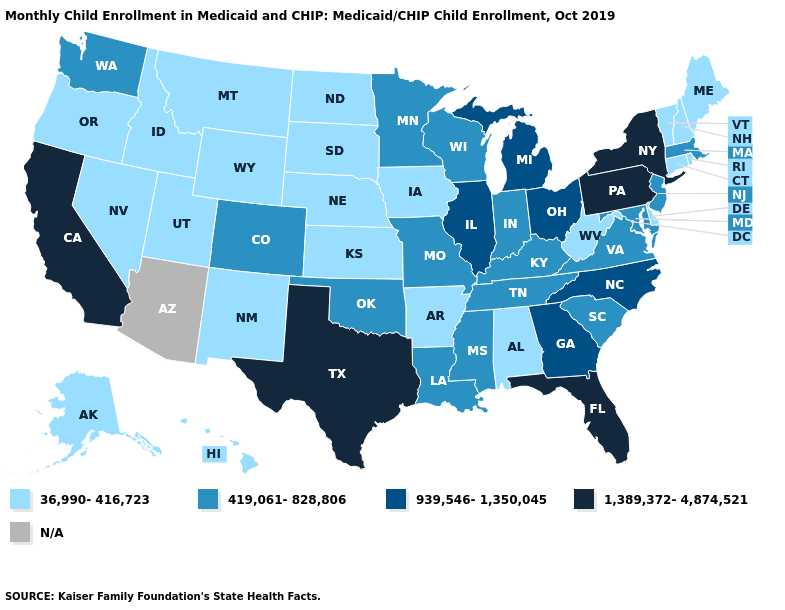Name the states that have a value in the range N/A?
Quick response, please. Arizona. Does the first symbol in the legend represent the smallest category?
Keep it brief. Yes. Name the states that have a value in the range 36,990-416,723?
Write a very short answer. Alabama, Alaska, Arkansas, Connecticut, Delaware, Hawaii, Idaho, Iowa, Kansas, Maine, Montana, Nebraska, Nevada, New Hampshire, New Mexico, North Dakota, Oregon, Rhode Island, South Dakota, Utah, Vermont, West Virginia, Wyoming. Name the states that have a value in the range 36,990-416,723?
Give a very brief answer. Alabama, Alaska, Arkansas, Connecticut, Delaware, Hawaii, Idaho, Iowa, Kansas, Maine, Montana, Nebraska, Nevada, New Hampshire, New Mexico, North Dakota, Oregon, Rhode Island, South Dakota, Utah, Vermont, West Virginia, Wyoming. What is the lowest value in states that border Tennessee?
Keep it brief. 36,990-416,723. Name the states that have a value in the range N/A?
Short answer required. Arizona. What is the value of Kentucky?
Be succinct. 419,061-828,806. Which states hav the highest value in the Northeast?
Keep it brief. New York, Pennsylvania. Is the legend a continuous bar?
Keep it brief. No. Name the states that have a value in the range 939,546-1,350,045?
Quick response, please. Georgia, Illinois, Michigan, North Carolina, Ohio. Does New York have the lowest value in the Northeast?
Answer briefly. No. What is the value of Idaho?
Give a very brief answer. 36,990-416,723. 